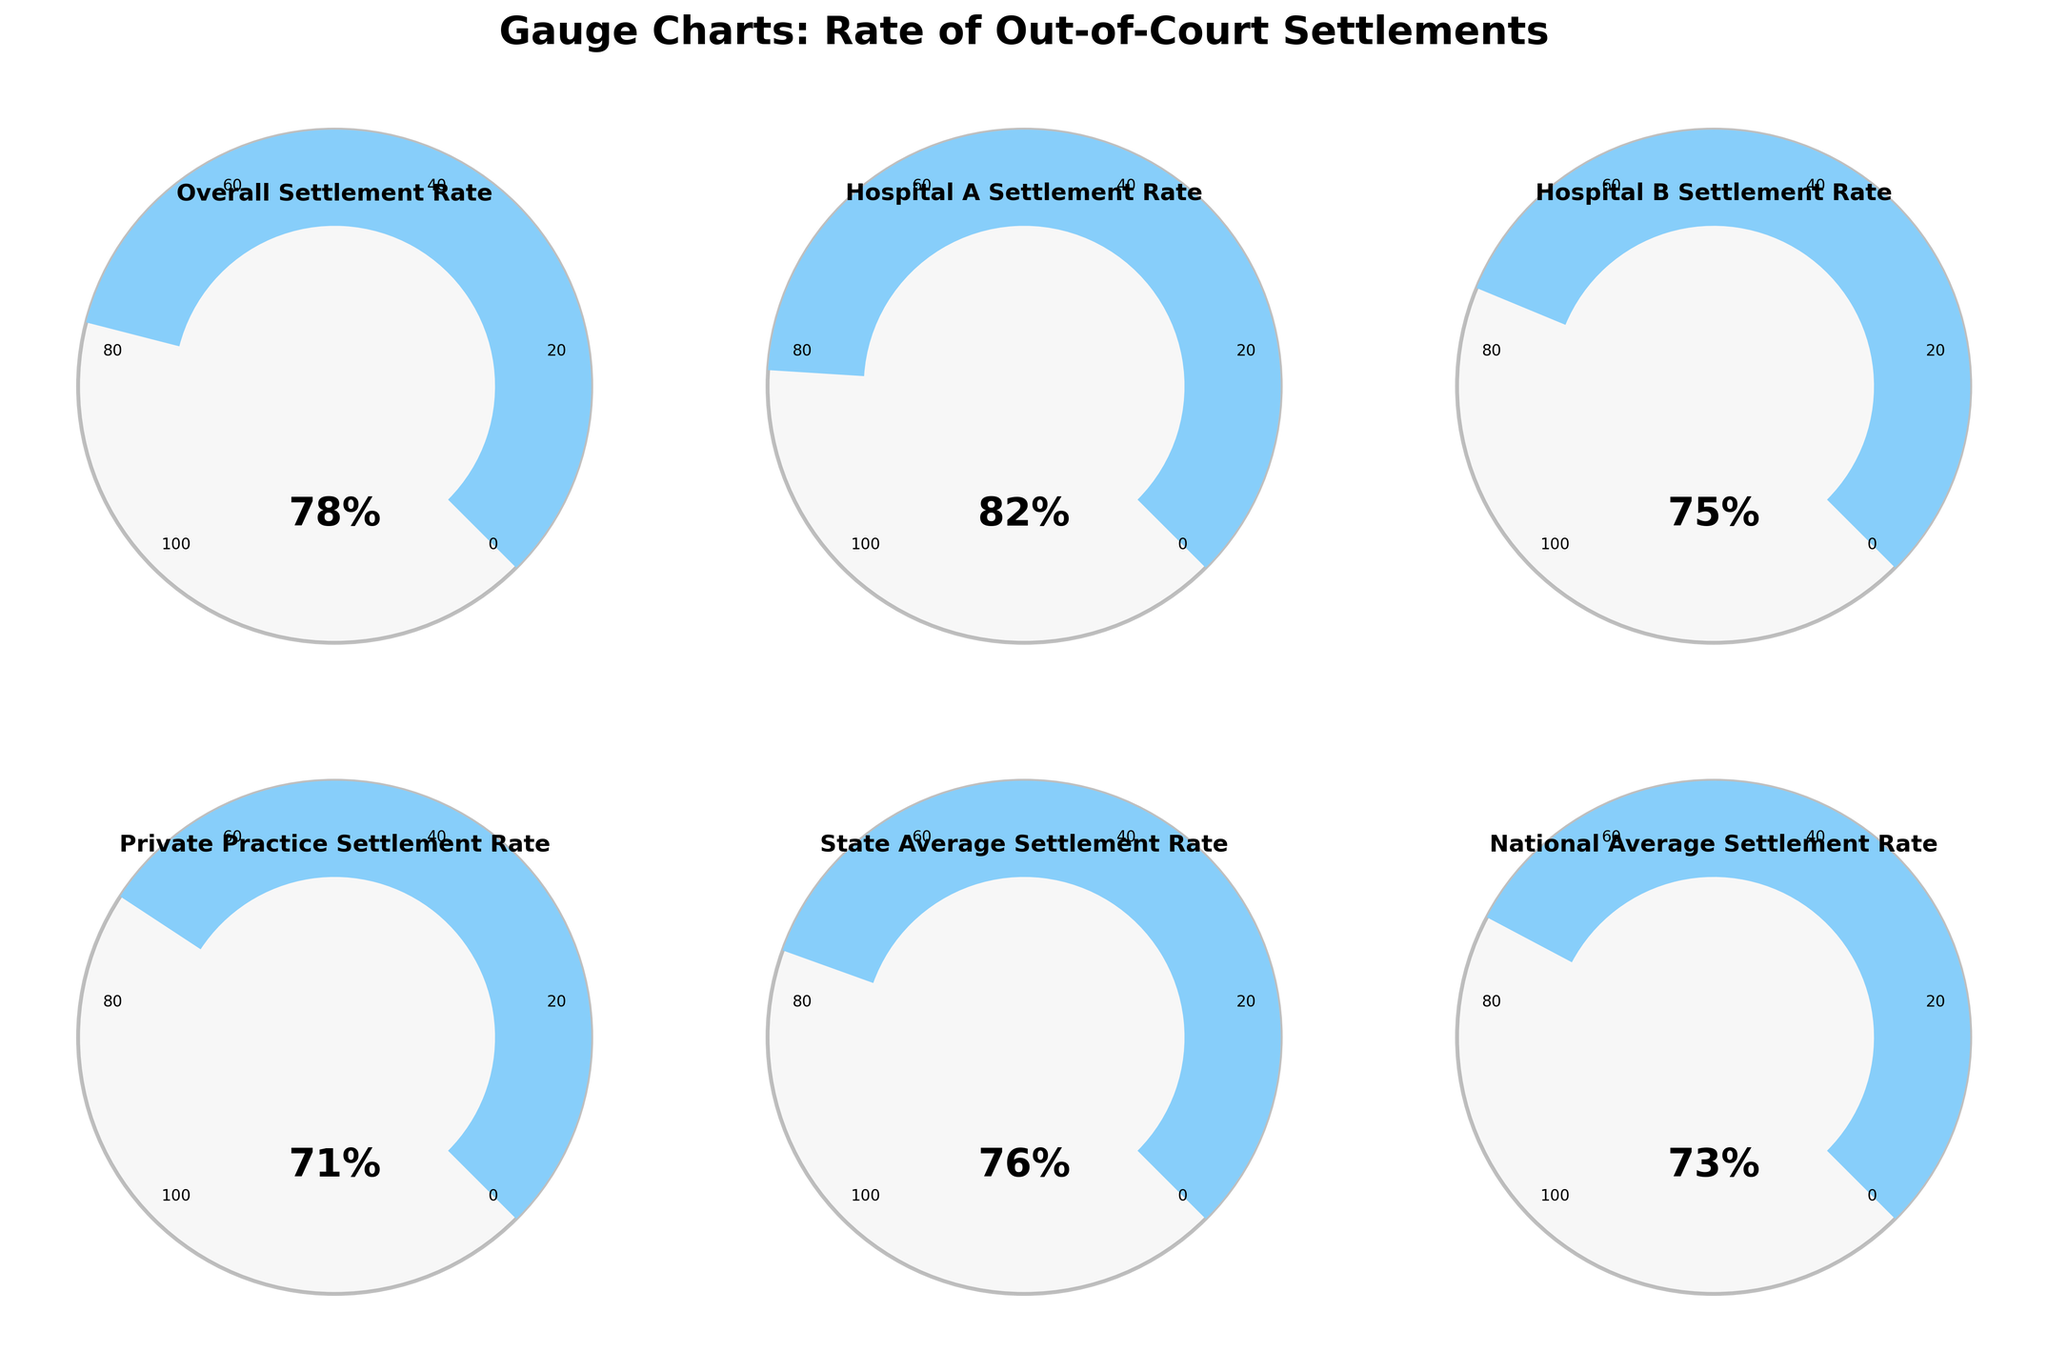What is the overall settlement rate for out-of-court settlements in medical negligence cases? The gauge for "Overall Settlement Rate" indicates a percentage value. Reading this value gives the overall rate.
Answer: 78% Which hospital has the highest rate of out-of-court settlements? By comparing the rates on each gauge, Hospital A has the highest rate at 82%.
Answer: Hospital A How does Hospital B's settlement rate compare to the national average? The gauge for Hospital B shows 75%, while the national average gauge shows 73%. 75% is greater than 73% by 2%.
Answer: Hospital B is higher by 2% What is the difference between the settlement rates of Hospital A and Private Practice? Read the values from the gauges: Hospital A - 82%, Private Practice - 71%. The difference is 82% - 71% = 11%.
Answer: 11% Is the state average settlement rate closer to the settlement rate of Hospital A or Hospital B? State Average: 76%, Hospital A: 82%, Hospital B: 75%. Calculate the differences:
Answer: Hospital B (by 1%) What's the combined average settlement rate for Hospital A and Hospital B? Add the two rates and divide by 2: (82% + 75%) / 2 = 78.5%
Answer: 78.5% Which settlement rate category has the closest percentage to the private practice settlement rate? Private Practice: 71%. Compare against other rates: State Average: 76%, National Average: 73%. National Average is closest by 2%.
Answer: National Average What color is used in the gauge representing the State Average Settlement Rate? Inspect the color used in the gauge for "State Average Settlement Rate" which falls in the intermediate range usually represented by light blue.
Answer: Light blue 